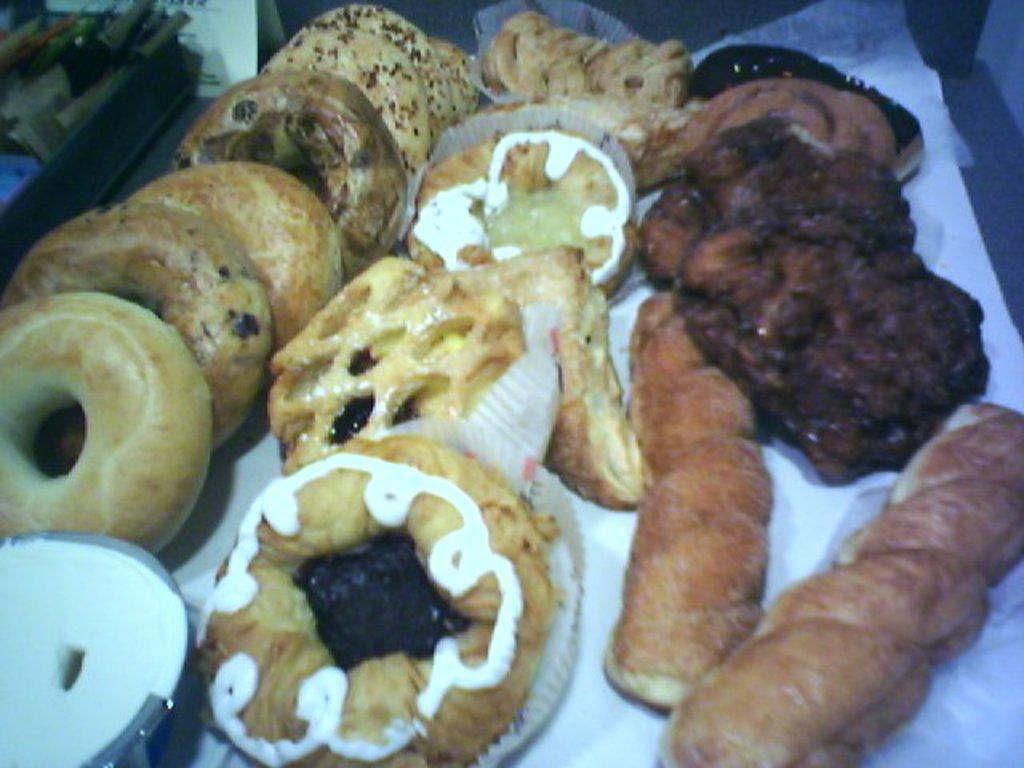What types of baked goods are present in the image? The image contains donuts, cookies, a cream roll, and a cream bun. Can you describe the cream-based items in the image? The image contains a cream roll and a cream bun. How many different types of baked goods are there in the image? There are four different types of baked goods in the image: donuts, cookies, a cream roll, and a cream bun. How does the wind affect the donuts in the image? There is no wind present in the image, and therefore it cannot affect the donuts. 